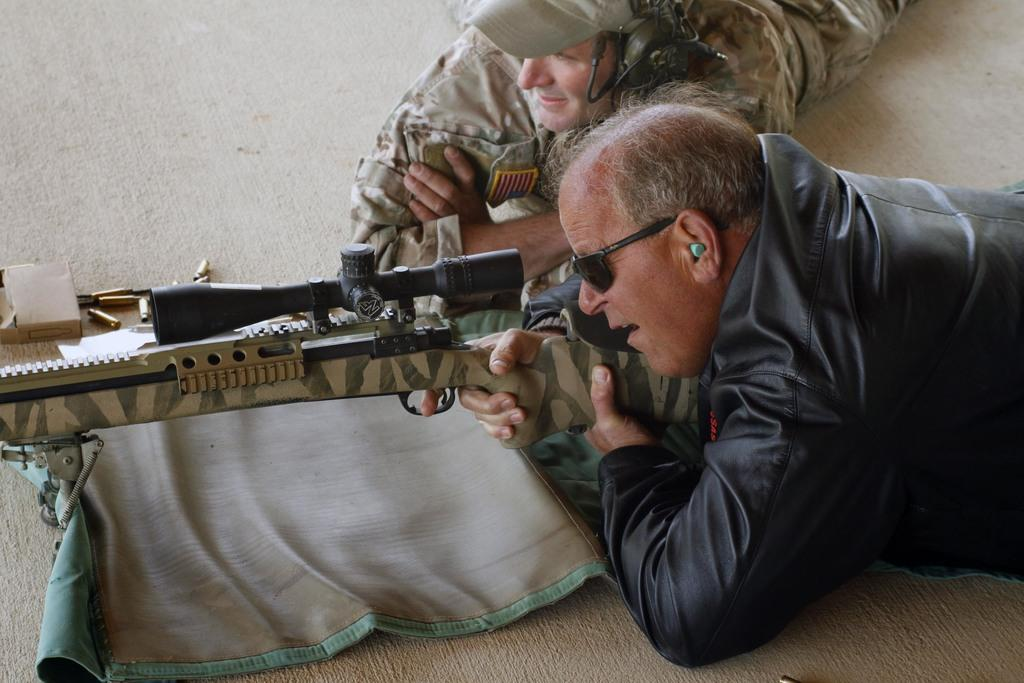Who is present at the bottom of the picture? There is a man in a black jacket at the bottom of the picture. What is the man holding in the image? The man is holding a gun. What objects can be seen on the left side of the image? There are bullets, a box, and a mat on the left side of the image. Who is present at the top of the image? There is a soldier at the top of the image. What is the soldier wearing in the image? The soldier is wearing a cap and headphones. What type of wine is being served on the branch in the image? There is no wine or branch present in the image. Can you describe the toad's reaction to the soldier at the top of the image? There is no toad present in the image. 